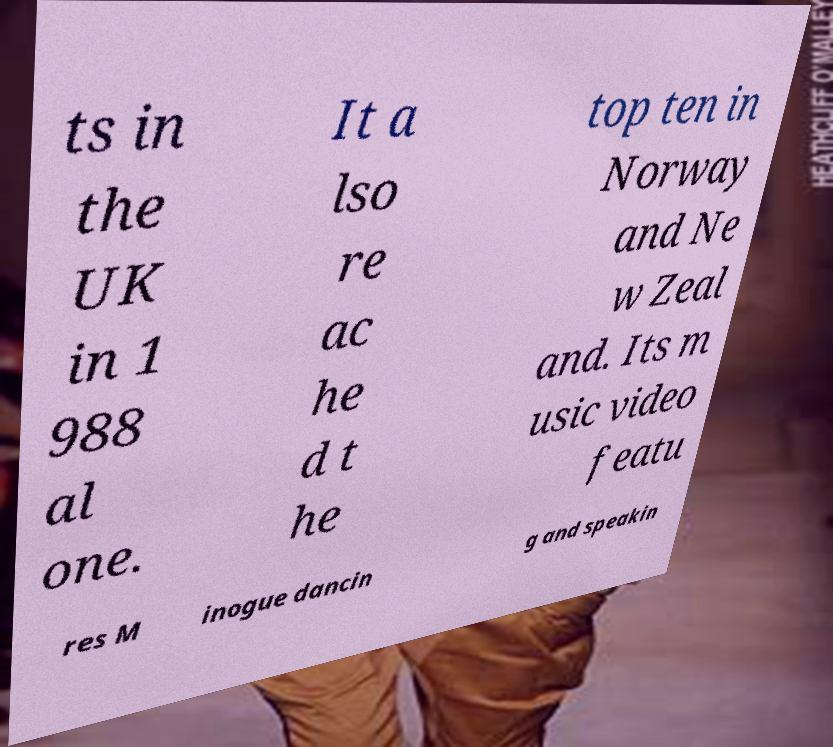Can you accurately transcribe the text from the provided image for me? ts in the UK in 1 988 al one. It a lso re ac he d t he top ten in Norway and Ne w Zeal and. Its m usic video featu res M inogue dancin g and speakin 